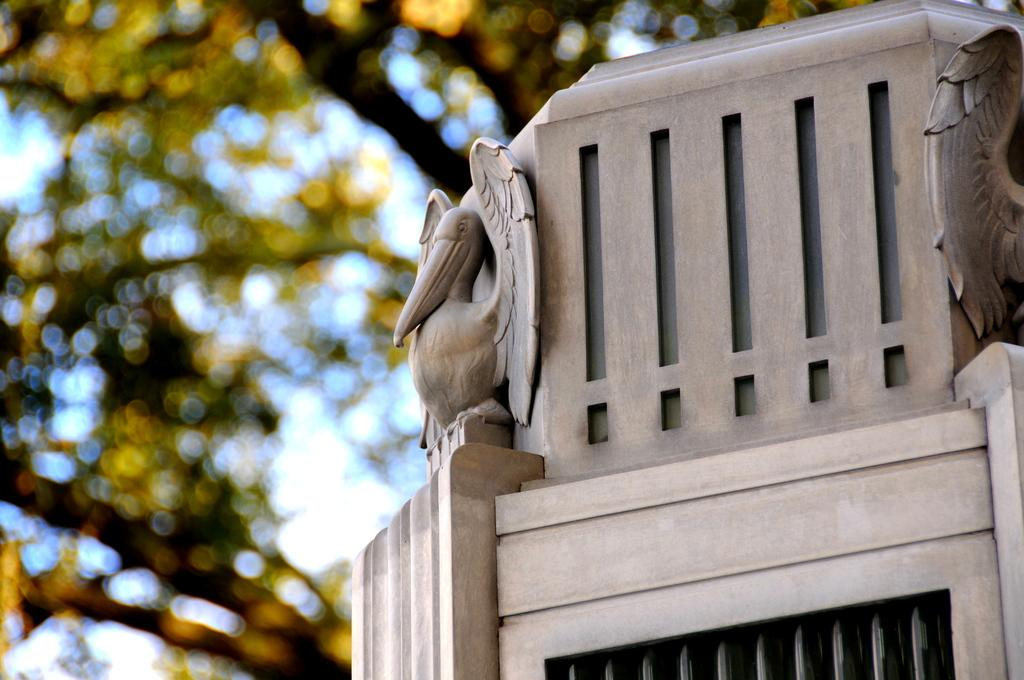What type of object is located on the right side of the image? There is a wooden object on the right side of the image. What can be seen in the background of the image? There are trees and a screen in the background of the image. Where is the girl standing in the image? There is no girl present in the image. What type of bait is being used by the scarecrow in the image? There is no scarecrow or bait present in the image. 